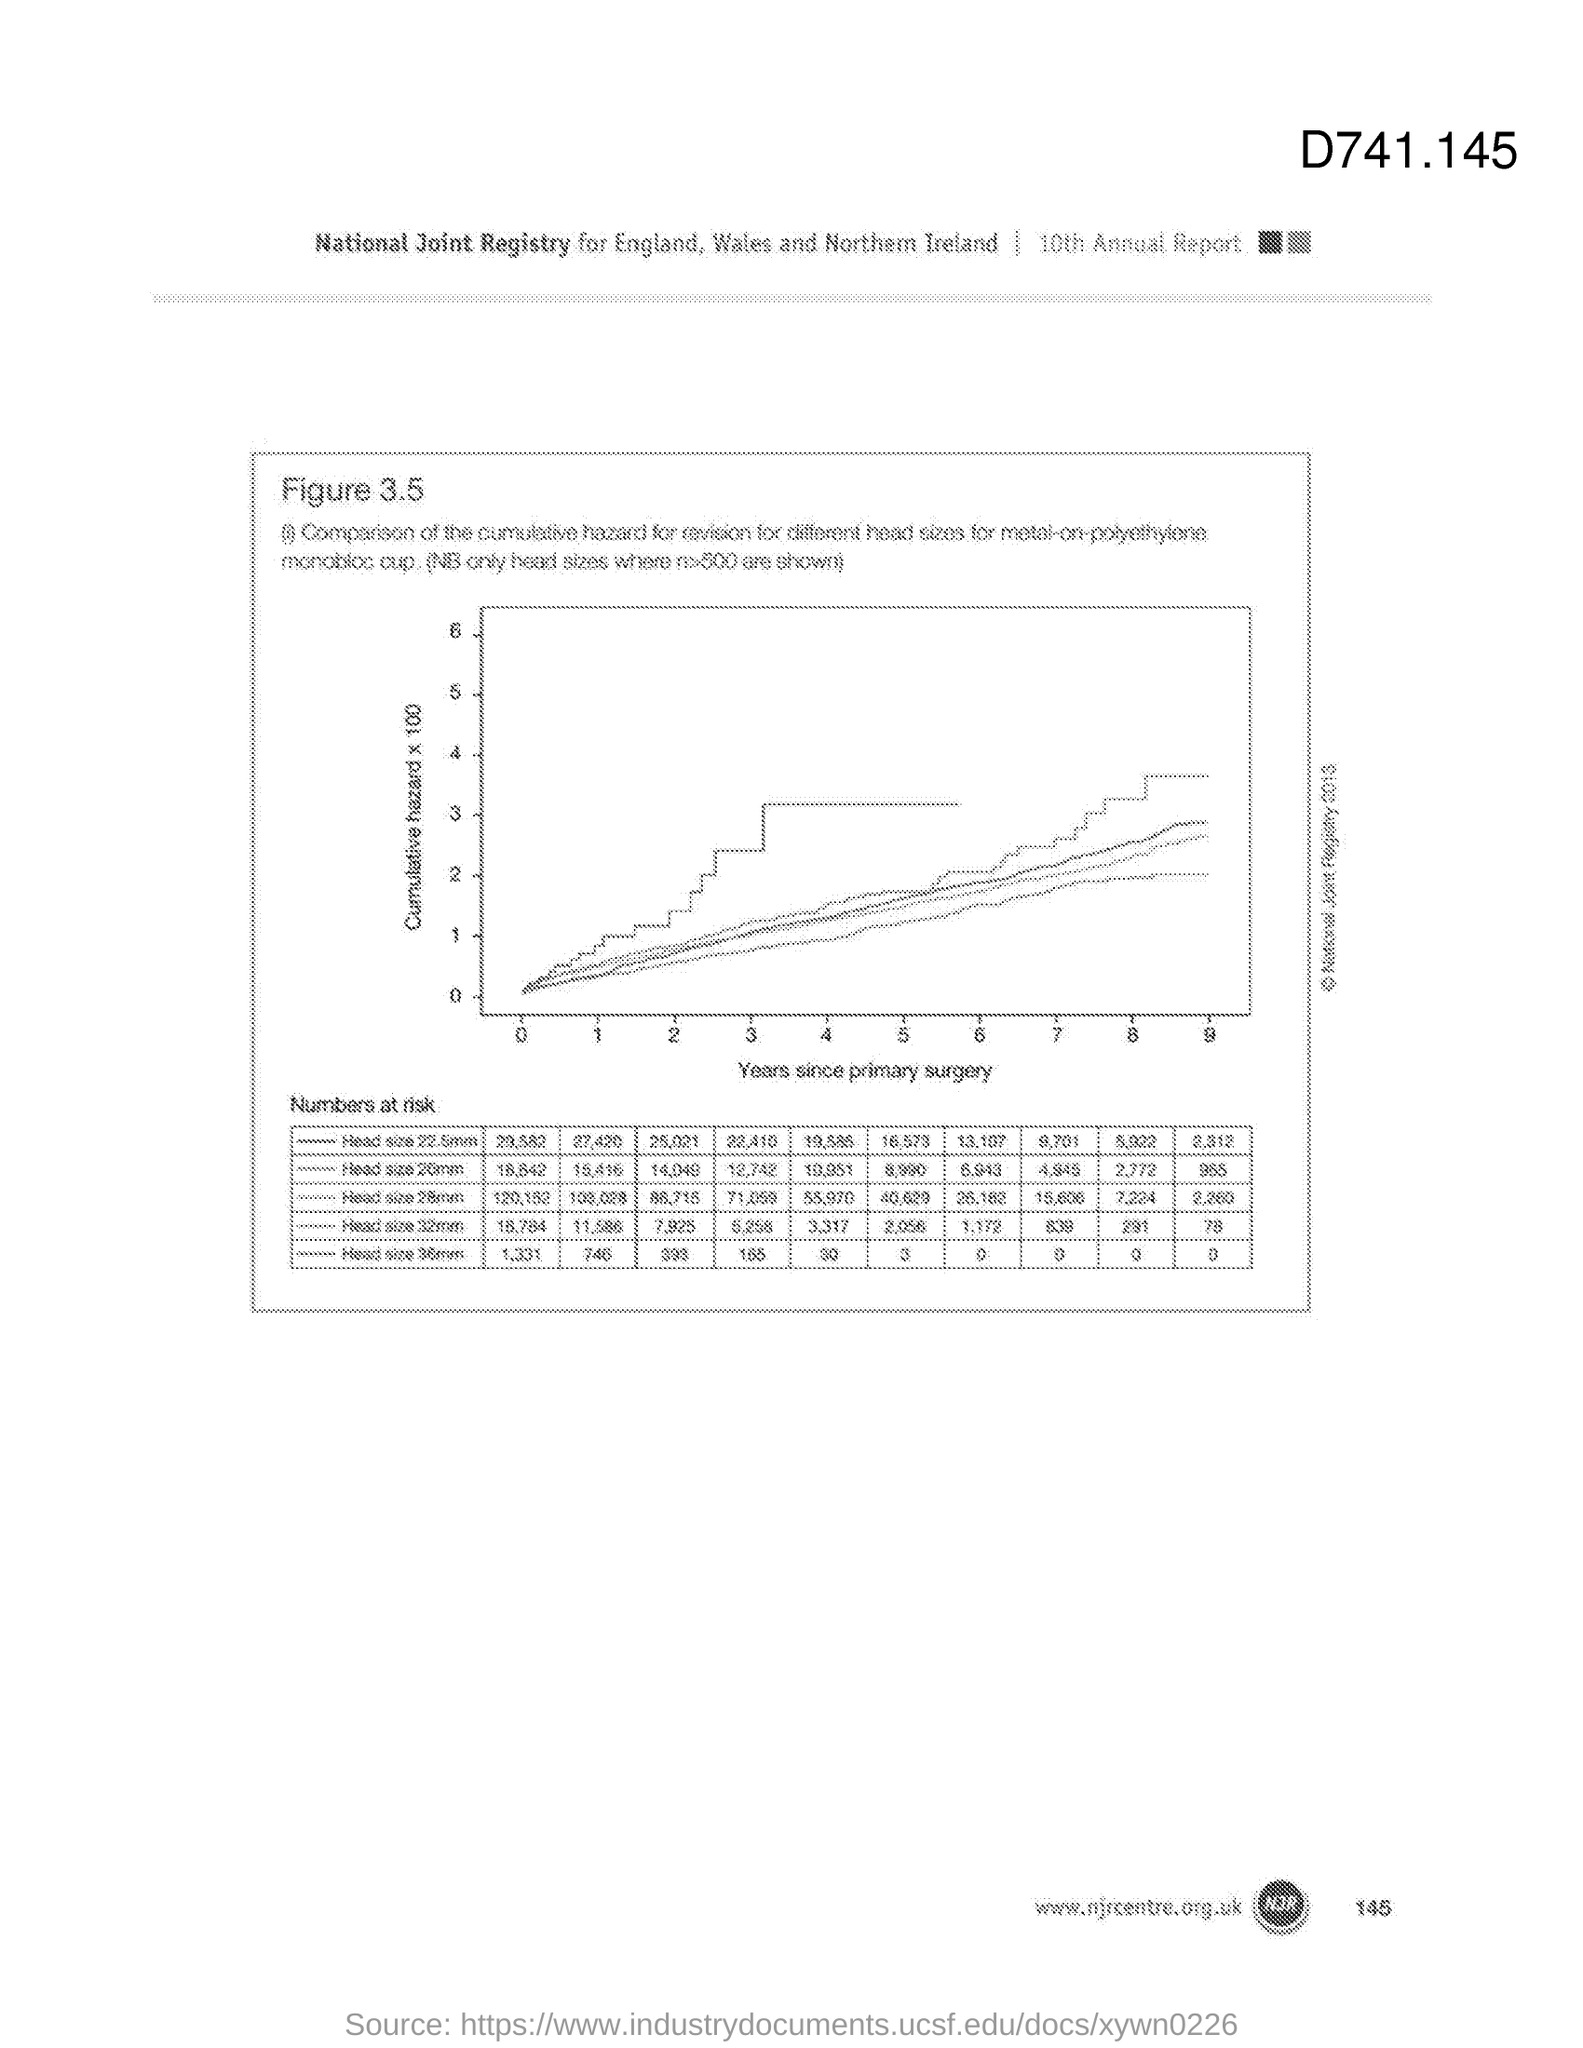What is the variable on X axis of the graph?
Offer a very short reply. Years since primary surgery. What is the variable on Y axis of the graph?
Make the answer very short. Cumulative hazard x 100. 